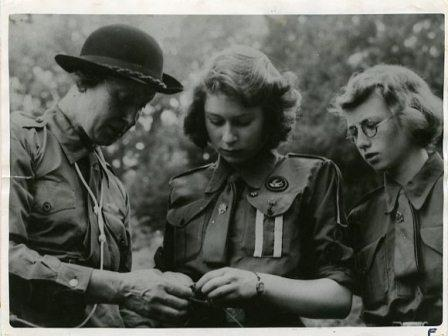What organization is the man's outfit from? Please explain your reasoning. boy scouts. The boy scouts are the entity that hands out these uniforms. 